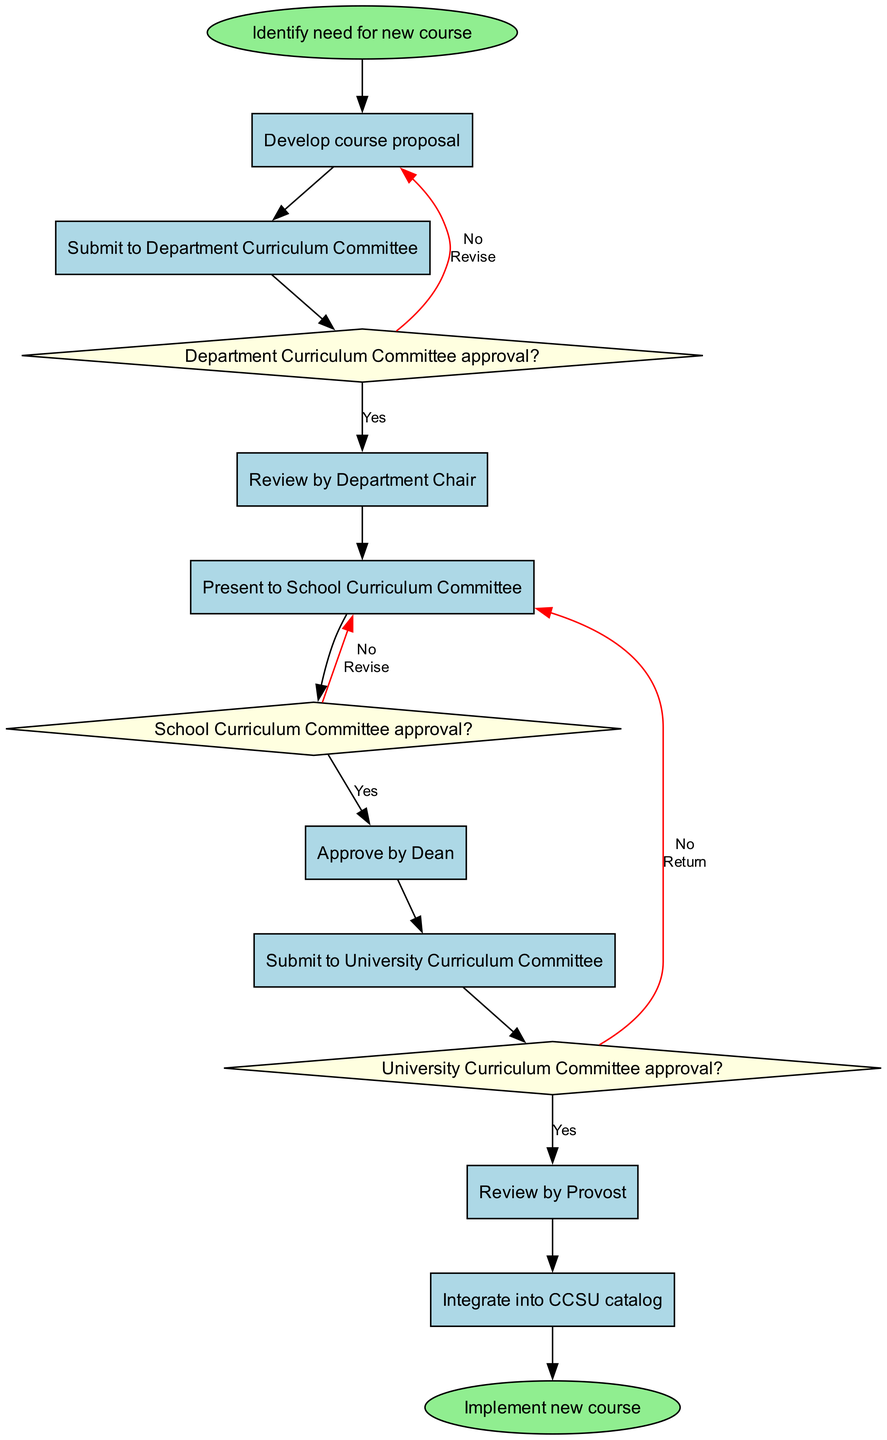What is the initial node in the diagram? The initial node is labeled as "Identify need for new course" and is located at the start of the flow, representing the beginning of the course development process.
Answer: Identify need for new course How many activities are present in the diagram? By counting the items listed under the activities section, there are specifically 8 activities shown in the diagram from the development of the course proposal to integrating it into the catalog.
Answer: 8 What is the final node in the diagram? The final node, which signifies the end of the process, is labeled as "Implement new course" and is shown at the end of the flow of activities and decisions in the diagram.
Answer: Implement new course What happens if the Department Curriculum Committee does not approve the proposal? If the Department Curriculum Committee does not approve the proposal, the flow indicates it leads back to revising the course proposal, as specified in the diagram.
Answer: Revise course proposal How many decision points are in the process? The diagram includes three decision points, each representing a crucial approval stage: one for the Department Curriculum Committee, one for the School Curriculum Committee, and one for the University Curriculum Committee.
Answer: 3 What is the relationship between the activity "Submit to University Curriculum Committee" and the decision "University Curriculum Committee approval?" The activity "Submit to University Curriculum Committee" directly leads to the decision point regarding "University Curriculum Committee approval?" indicating that this decision is contingent upon the submission of the proposal to the committee.
Answer: Directly leads to What should be done if the School Curriculum Committee does not approve the proposal? According to the diagram, if the School Curriculum Committee does not approve the proposal, it indicates that the proposal should be revised and resubmitted as part of the process.
Answer: Revise and resubmit What is the pathway for the course proposal if it receives approval from all committees? If the proposal gains approval from all committees, it follows the path through each of the approvals sequentially, moving from the "Review by Provost" to the final node "Implement new course" without any revisions needed.
Answer: Implement new course What color are the decision nodes displayed in the diagram? The decision nodes are specifically colored light yellow, distinguishing them from other nodes and indicating a point of decision-making in the process.
Answer: Light yellow 